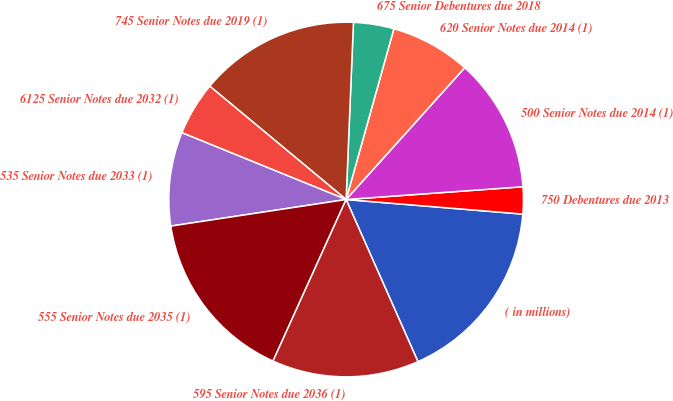Convert chart. <chart><loc_0><loc_0><loc_500><loc_500><pie_chart><fcel>( in millions)<fcel>750 Debentures due 2013<fcel>500 Senior Notes due 2014 (1)<fcel>620 Senior Notes due 2014 (1)<fcel>675 Senior Debentures due 2018<fcel>745 Senior Notes due 2019 (1)<fcel>6125 Senior Notes due 2032 (1)<fcel>535 Senior Notes due 2033 (1)<fcel>555 Senior Notes due 2035 (1)<fcel>595 Senior Notes due 2036 (1)<nl><fcel>17.05%<fcel>2.46%<fcel>12.19%<fcel>7.32%<fcel>3.68%<fcel>14.62%<fcel>4.89%<fcel>8.54%<fcel>15.84%<fcel>13.4%<nl></chart> 